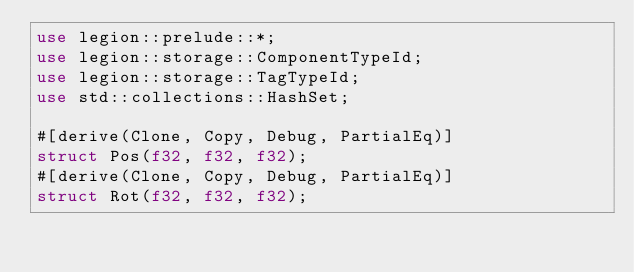Convert code to text. <code><loc_0><loc_0><loc_500><loc_500><_Rust_>use legion::prelude::*;
use legion::storage::ComponentTypeId;
use legion::storage::TagTypeId;
use std::collections::HashSet;

#[derive(Clone, Copy, Debug, PartialEq)]
struct Pos(f32, f32, f32);
#[derive(Clone, Copy, Debug, PartialEq)]
struct Rot(f32, f32, f32);</code> 